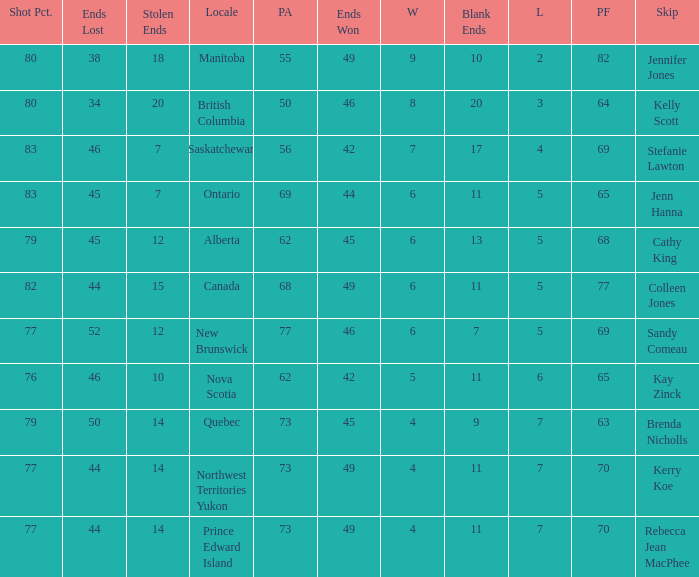What is the PA when the PF is 77? 68.0. 